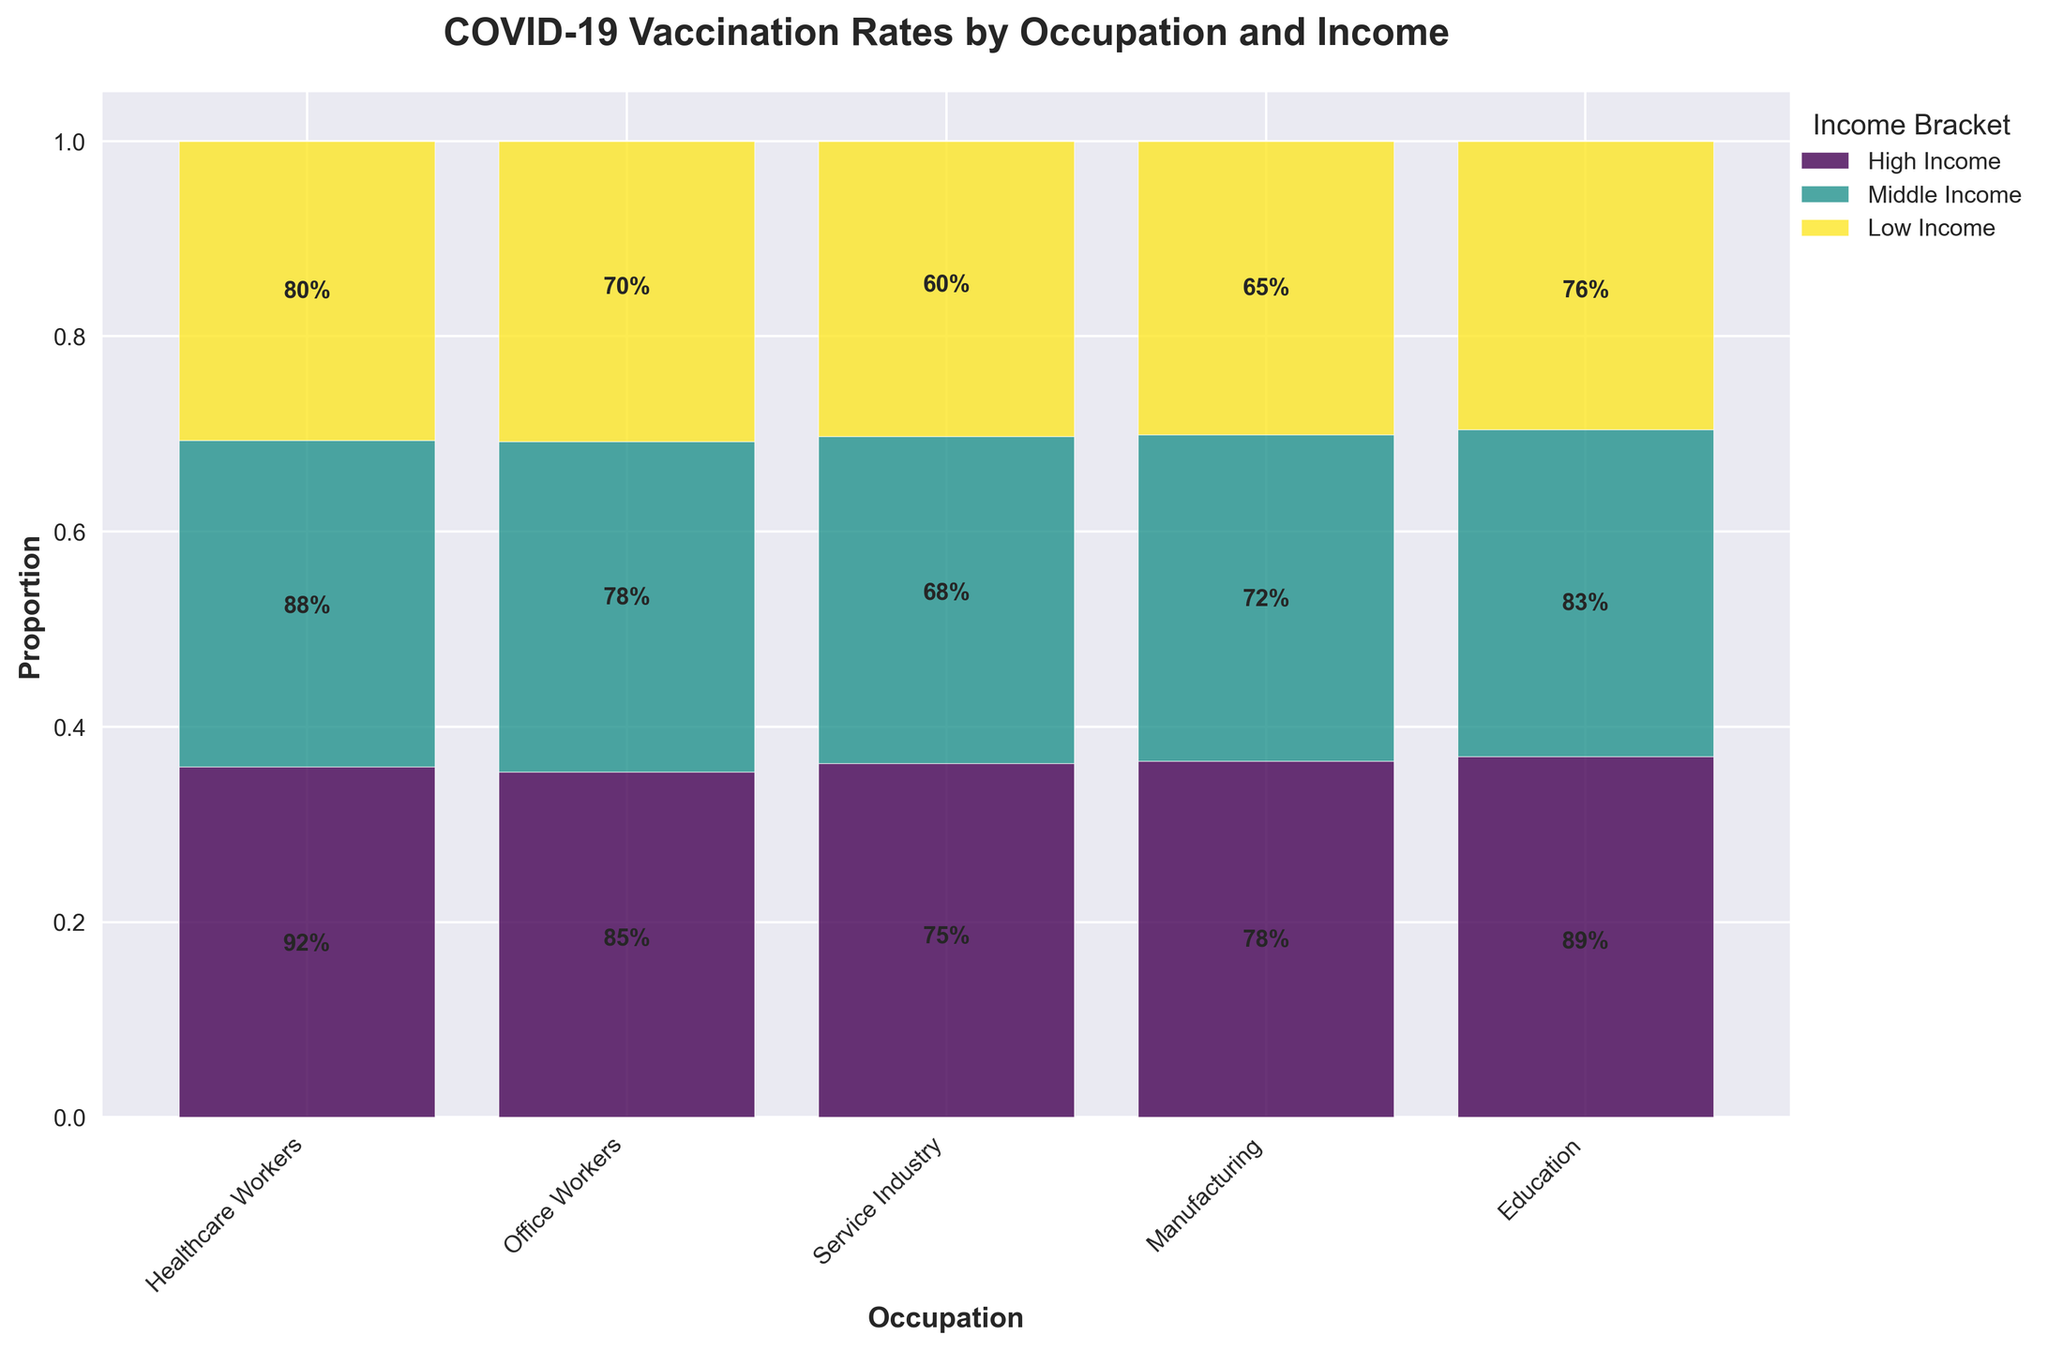What is the title of the plot? The title of the plot is displayed at the top and usually provides a summary of what the plot represents. In this case, the title reads "COVID-19 Vaccination Rates by Occupation and Income".
Answer: COVID-19 Vaccination Rates by Occupation and Income Which occupation has the highest vaccination rate in the high-income bracket? By looking at the highest bar heights in the 'High Income' segment, we see that Healthcare Workers have the highest vaccination rate of 92%.
Answer: Healthcare Workers Which occupation and income bracket combination has the lowest vaccination rate? By observing the smallest segment across all bars, Service Industry workers in the Low Income bracket show the smallest value of 60%.
Answer: Service Industry, Low Income What is the vaccination rate for Office Workers in the middle-income bracket? We look at the intersection of Office Workers and the middle-income color segment, which is indicated to have a vaccination rate of 78%.
Answer: 78% How much higher is the vaccination rate for Healthcare Workers compared to Service Industry workers in the Low Income bracket? The vaccination rate for Healthcare Workers in the Low Income bracket is 80%, while for Service Industry workers in the same bracket, it is 60%. Subtract the lower rate from the higher rate: 80% - 60% = 20%.
Answer: 20% Which income bracket generally shows the lowest vaccination rates across most occupations? By looking at the plots, the Low Income bracket consistently has the shortest bar heights across all occupations, indicating the lowest vaccination rates.
Answer: Low Income Do teachers have a higher vaccination rate in the middle-income bracket than office workers? Looking at the bars for Education and Office Workers in the middle-income color, Education has a rate of 83%, and Office Workers have 78%. Comparison shows that Education has a higher rate.
Answer: Yes How much does the vaccination rate for high-income Manufacturing workers differ from middle-income Manufacturing workers? Refer to the bar heights for Manufacturing in high-income (78%) and middle-income (72%) brackets. The difference is calculated as 78% - 72% = 6%.
Answer: 6% What proportion of Healthcare Workers' vaccination rates falls under the high-income bracket? For Healthcare Workers, the high-income bracket shows a segment with a rate of 92%. Normalize proportion from the bar adds up the individual normalized heights. Since only normalized proportions are visualized, the precise visual space proportion must be approximated.
Answer: Highest In the context of this plot, which group had consistently above-average vaccination rates regardless of income bracket? By examining each occupation across all income brackets, Healthcare Workers consistently have higher segment heights in each income level compared with other professions, indicating consistently above-average vaccination rates.
Answer: Healthcare Workers 